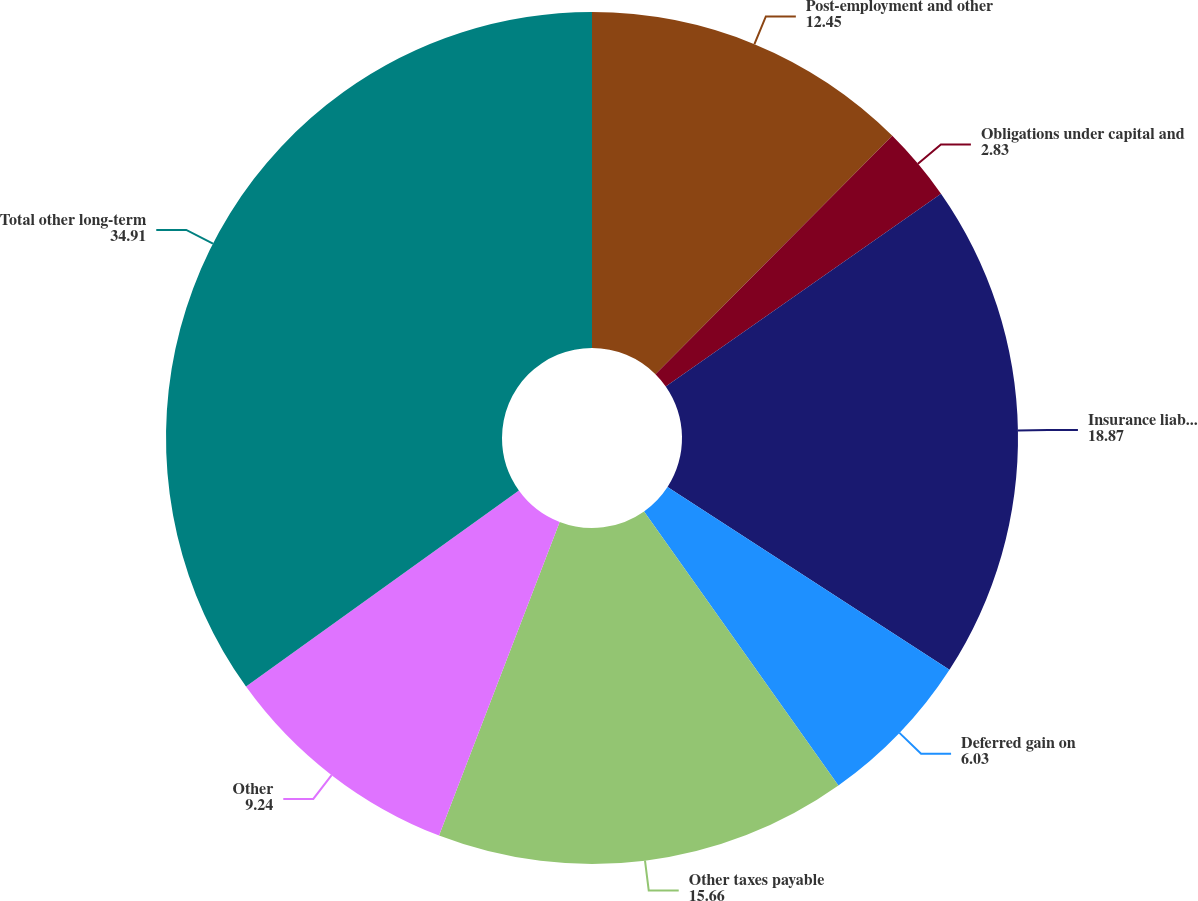<chart> <loc_0><loc_0><loc_500><loc_500><pie_chart><fcel>Post-employment and other<fcel>Obligations under capital and<fcel>Insurance liabilities<fcel>Deferred gain on<fcel>Other taxes payable<fcel>Other<fcel>Total other long-term<nl><fcel>12.45%<fcel>2.83%<fcel>18.87%<fcel>6.03%<fcel>15.66%<fcel>9.24%<fcel>34.91%<nl></chart> 